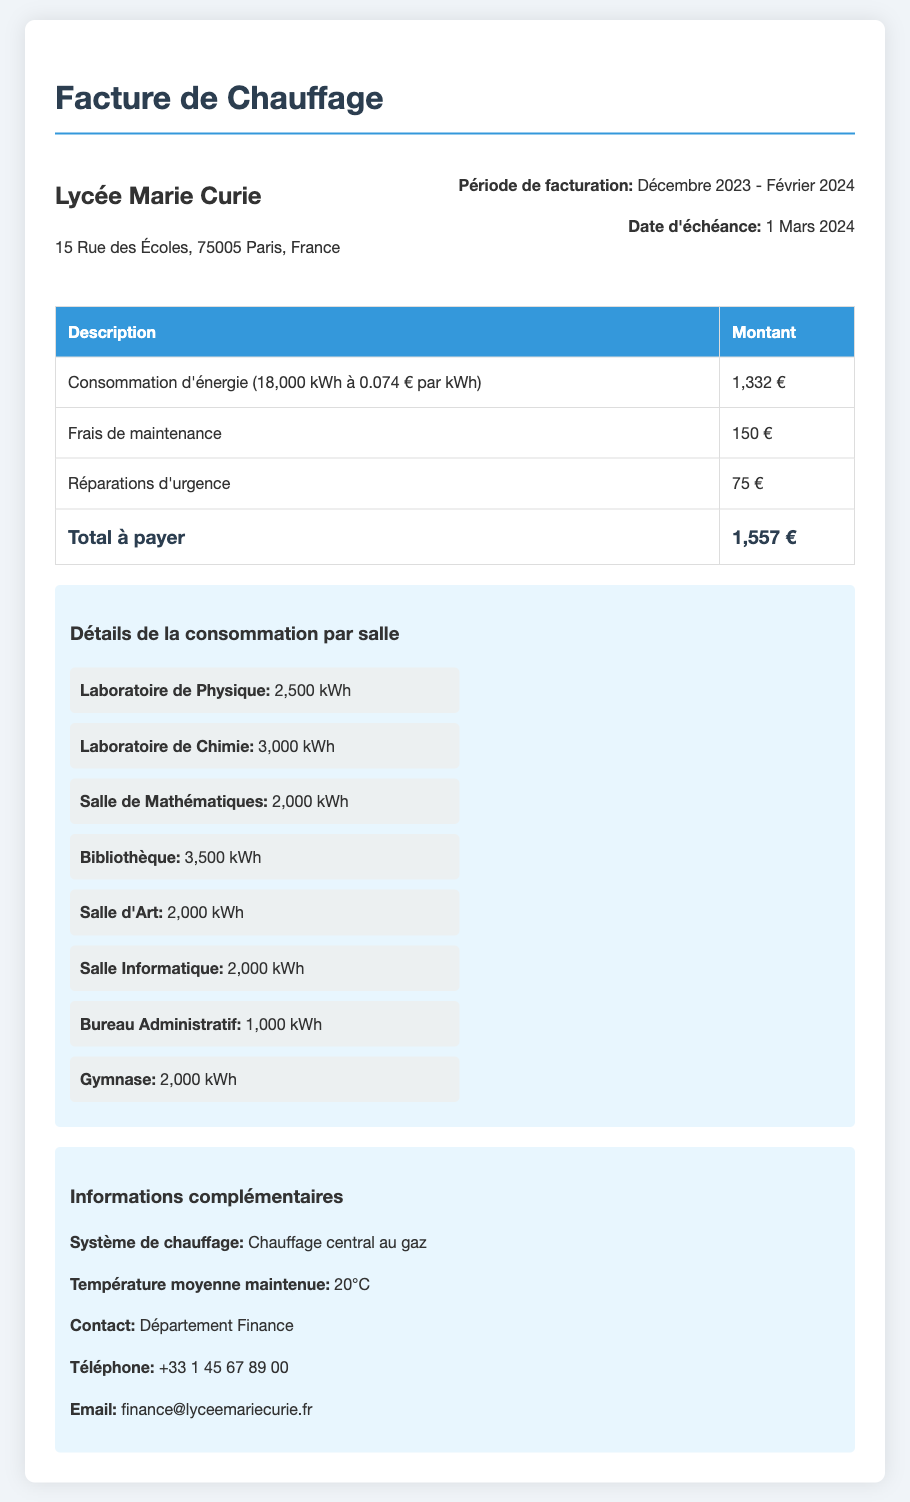Quel est le total à payer pour la facture de chauffage ? Le total à payer est indiqué dans le tableau des coûts, qui cumule toutes les charges.
Answer: 1,557 € Quelle est la consommation d'énergie totale en kWh ? La consommation d'énergie totale est spécifiée dans la première ligne du tableau des coûts.
Answer: 18,000 kWh Quel est le coût par kWh consommé ? Le coût par kWh est mentionné dans la description de la consommation d'énergie dans le tableau.
Answer: 0.074 € Quelle est la période de facturation ? La période de facturation est précisée dans la section d'informations sur la facture.
Answer: Décembre 2023 - Février 2024 Quel est le montant des frais de maintenance ? Le montant des frais de maintenance est indiqué dans le tableau des coûts.
Answer: 150 € Combien d'énergie a été consommée par le Laboratoire de Chimie ? La consommation d'énergie du Laboratoire de Chimie est spécifiée dans la section des détails de la consommation par salle.
Answer: 3,000 kWh Quel est le système de chauffage utilisé dans l'école ? Le type de système de chauffage est donné dans les informations complémentaires.
Answer: Chauffage central au gaz Quel est le contact pour des informations financières ? Le contact pour des informations financières est mentionné dans la section des informations complémentaires.
Answer: Département Finance 